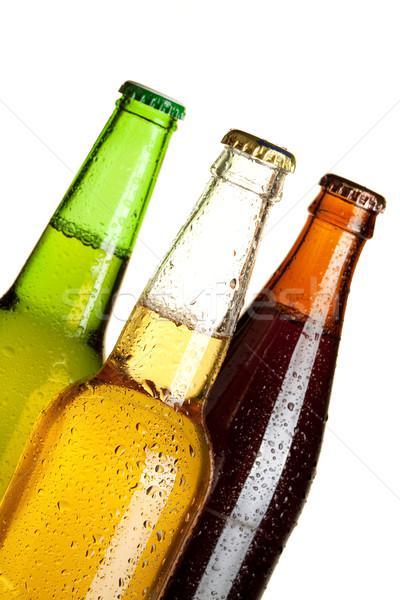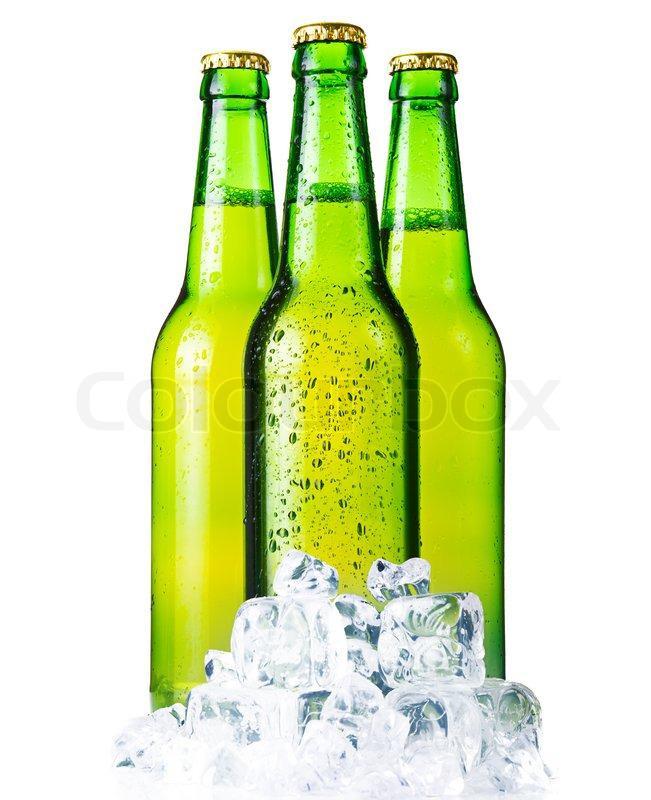The first image is the image on the left, the second image is the image on the right. Examine the images to the left and right. Is the description "All beer bottles are standing upright." accurate? Answer yes or no. No. The first image is the image on the left, the second image is the image on the right. For the images shown, is this caption "There are three green glass bottles" true? Answer yes or no. No. 